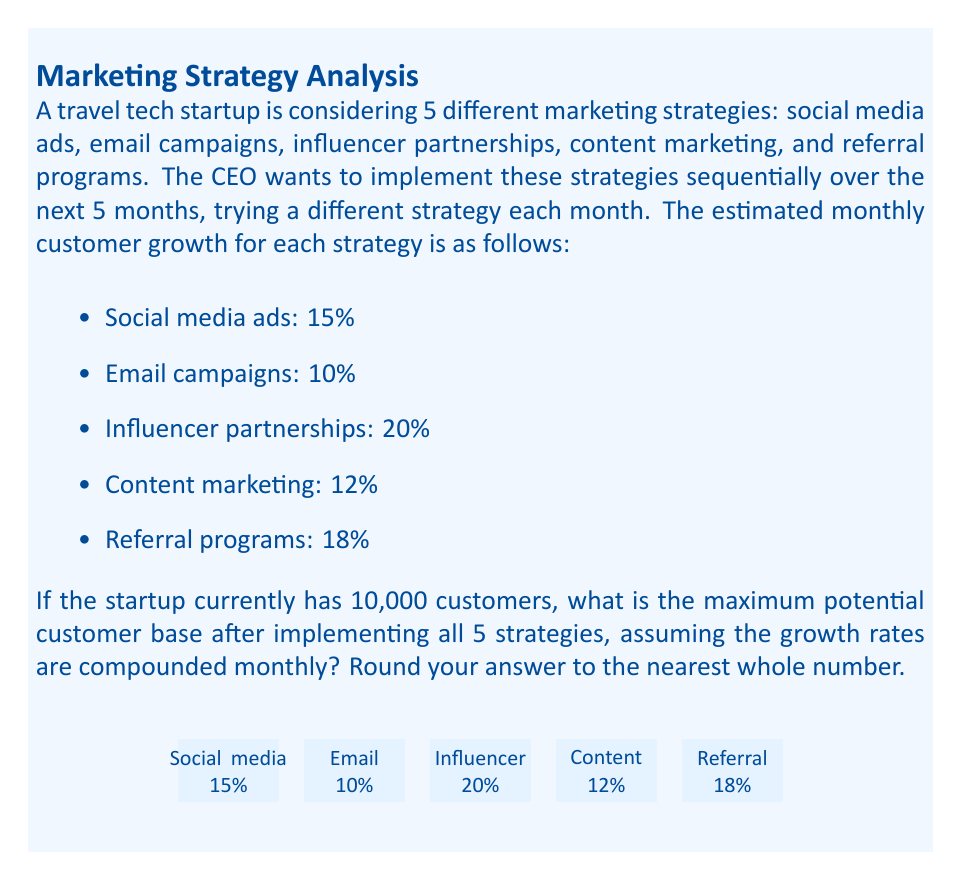Show me your answer to this math problem. To maximize the potential customer base, we need to implement the strategies in descending order of their growth rates. Let's order them from highest to lowest:

1. Influencer partnerships: 20%
2. Referral programs: 18%
3. Social media ads: 15%
4. Content marketing: 12%
5. Email campaigns: 10%

Now, let's calculate the compounded growth month by month:

1. Month 1 (Influencer partnerships):
   $10,000 \times (1 + 0.20) = 12,000$ customers

2. Month 2 (Referral programs):
   $12,000 \times (1 + 0.18) = 14,160$ customers

3. Month 3 (Social media ads):
   $14,160 \times (1 + 0.15) = 16,284$ customers

4. Month 4 (Content marketing):
   $16,284 \times (1 + 0.12) = 18,238.08$ customers

5. Month 5 (Email campaigns):
   $18,238.08 \times (1 + 0.10) = 20,061.888$ customers

The final calculation can be expressed as:

$$10,000 \times (1 + 0.20) \times (1 + 0.18) \times (1 + 0.15) \times (1 + 0.12) \times (1 + 0.10) = 20,061.888$$

Rounding to the nearest whole number gives us 20,062 customers.
Answer: 20,062 customers 